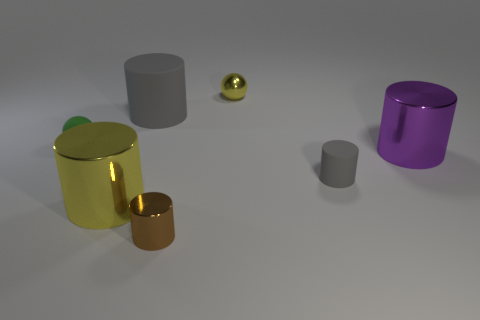What shape is the tiny yellow metallic thing? sphere 